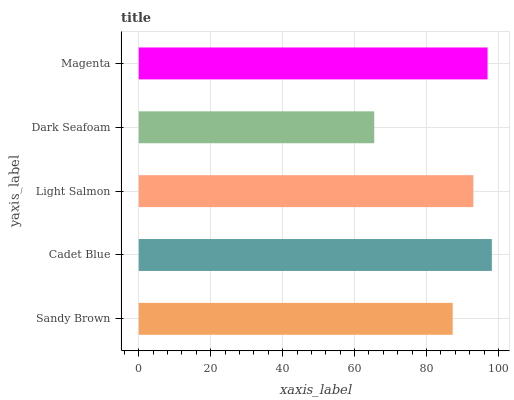Is Dark Seafoam the minimum?
Answer yes or no. Yes. Is Cadet Blue the maximum?
Answer yes or no. Yes. Is Light Salmon the minimum?
Answer yes or no. No. Is Light Salmon the maximum?
Answer yes or no. No. Is Cadet Blue greater than Light Salmon?
Answer yes or no. Yes. Is Light Salmon less than Cadet Blue?
Answer yes or no. Yes. Is Light Salmon greater than Cadet Blue?
Answer yes or no. No. Is Cadet Blue less than Light Salmon?
Answer yes or no. No. Is Light Salmon the high median?
Answer yes or no. Yes. Is Light Salmon the low median?
Answer yes or no. Yes. Is Dark Seafoam the high median?
Answer yes or no. No. Is Magenta the low median?
Answer yes or no. No. 